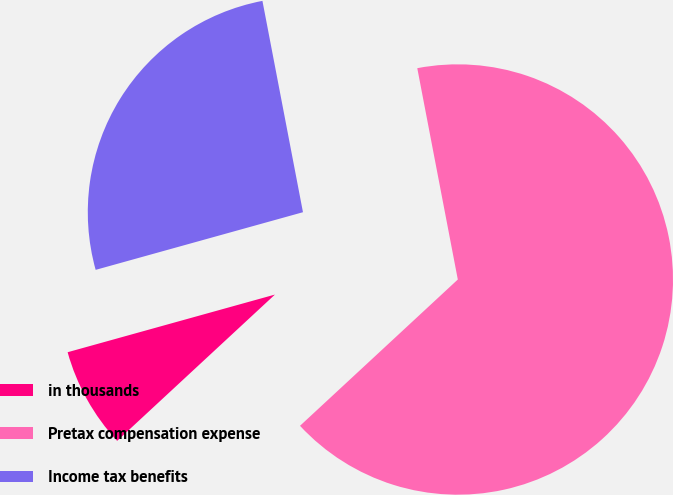<chart> <loc_0><loc_0><loc_500><loc_500><pie_chart><fcel>in thousands<fcel>Pretax compensation expense<fcel>Income tax benefits<nl><fcel>7.58%<fcel>66.12%<fcel>26.3%<nl></chart> 